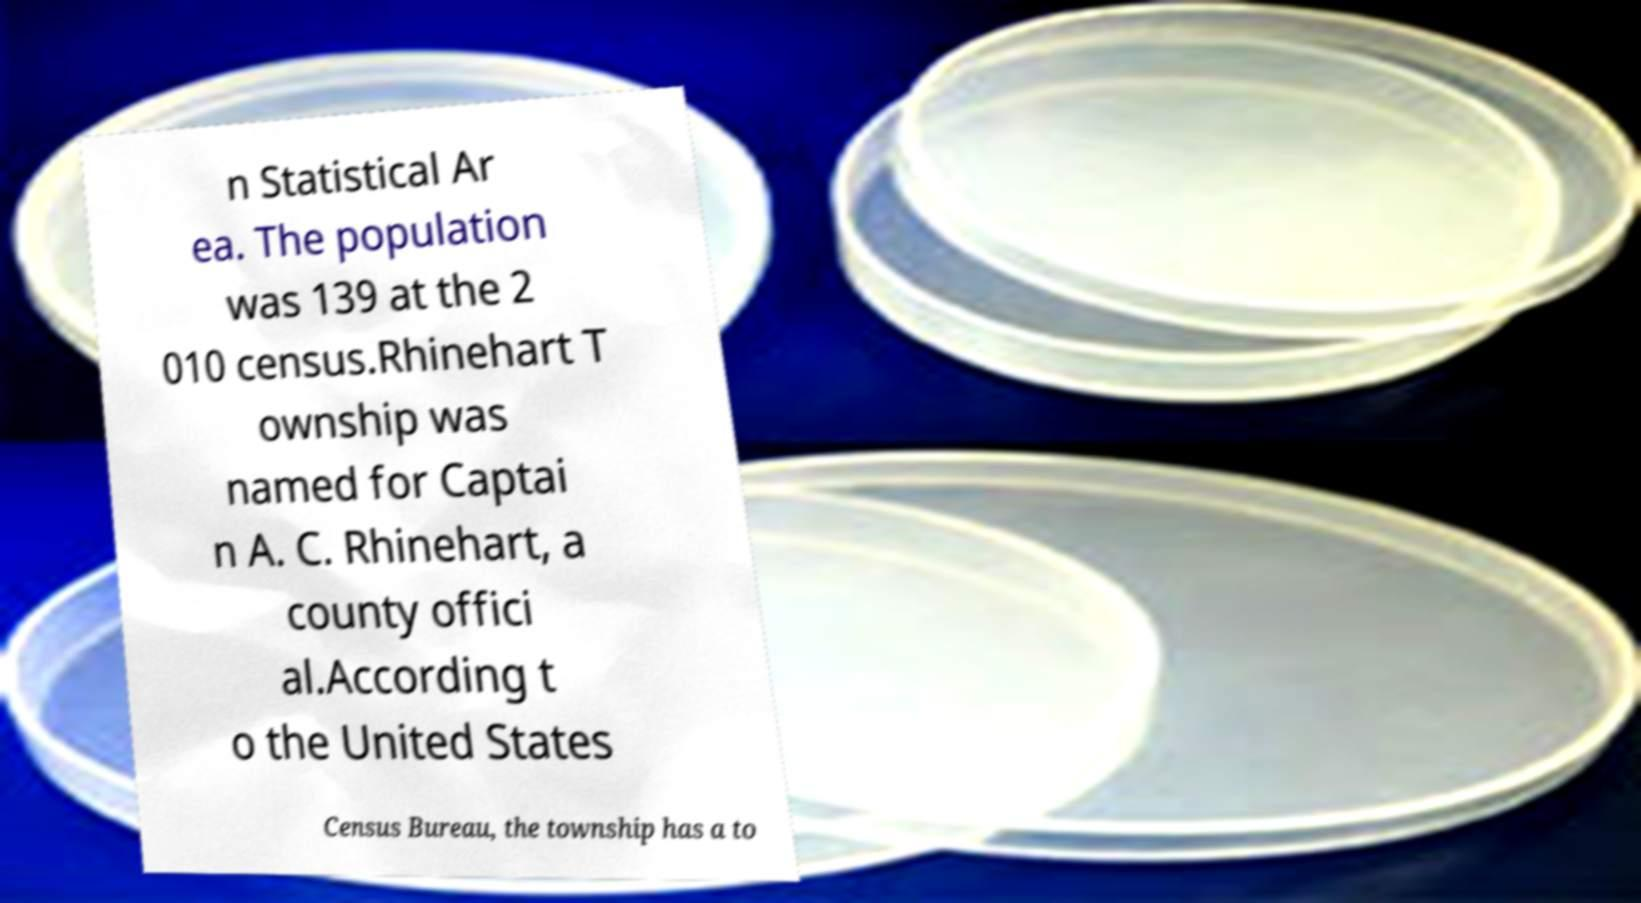I need the written content from this picture converted into text. Can you do that? n Statistical Ar ea. The population was 139 at the 2 010 census.Rhinehart T ownship was named for Captai n A. C. Rhinehart, a county offici al.According t o the United States Census Bureau, the township has a to 